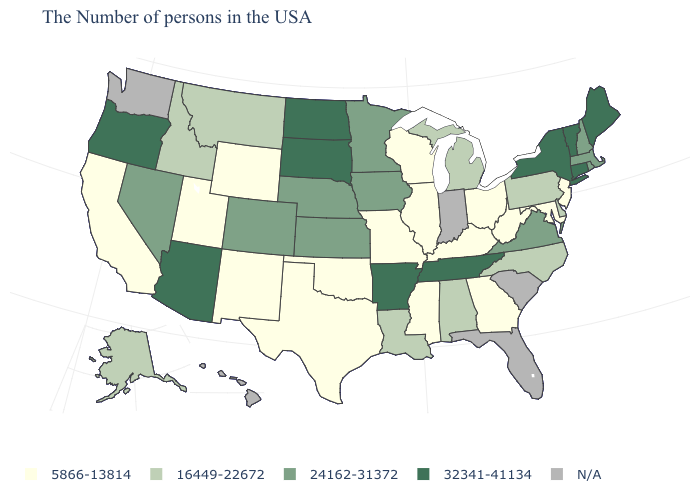How many symbols are there in the legend?
Be succinct. 5. What is the lowest value in the USA?
Keep it brief. 5866-13814. Name the states that have a value in the range N/A?
Give a very brief answer. South Carolina, Florida, Indiana, Washington, Hawaii. What is the lowest value in the West?
Keep it brief. 5866-13814. What is the value of Nebraska?
Write a very short answer. 24162-31372. Name the states that have a value in the range 5866-13814?
Short answer required. New Jersey, Maryland, West Virginia, Ohio, Georgia, Kentucky, Wisconsin, Illinois, Mississippi, Missouri, Oklahoma, Texas, Wyoming, New Mexico, Utah, California. What is the highest value in states that border Connecticut?
Answer briefly. 32341-41134. Name the states that have a value in the range 16449-22672?
Quick response, please. Delaware, Pennsylvania, North Carolina, Michigan, Alabama, Louisiana, Montana, Idaho, Alaska. Is the legend a continuous bar?
Answer briefly. No. What is the value of Hawaii?
Short answer required. N/A. Does the map have missing data?
Concise answer only. Yes. Name the states that have a value in the range 5866-13814?
Concise answer only. New Jersey, Maryland, West Virginia, Ohio, Georgia, Kentucky, Wisconsin, Illinois, Mississippi, Missouri, Oklahoma, Texas, Wyoming, New Mexico, Utah, California. Is the legend a continuous bar?
Write a very short answer. No. Among the states that border South Carolina , which have the lowest value?
Quick response, please. Georgia. What is the lowest value in states that border Wyoming?
Quick response, please. 5866-13814. 